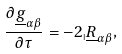<formula> <loc_0><loc_0><loc_500><loc_500>\frac { \partial \underline { g } _ { \alpha \beta } } { \partial \tau } = - 2 _ { \shortmid } \underline { R } _ { \alpha \beta } ,</formula> 